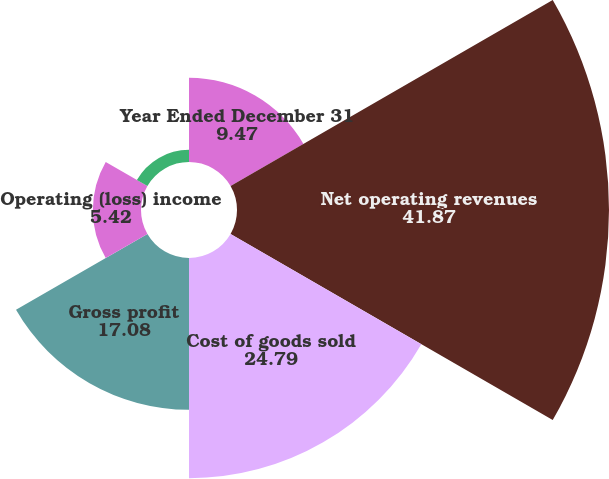Convert chart to OTSL. <chart><loc_0><loc_0><loc_500><loc_500><pie_chart><fcel>Year Ended December 31<fcel>Net operating revenues<fcel>Cost of goods sold<fcel>Gross profit<fcel>Operating (loss) income<fcel>Net (loss) income<nl><fcel>9.47%<fcel>41.87%<fcel>24.79%<fcel>17.08%<fcel>5.42%<fcel>1.37%<nl></chart> 